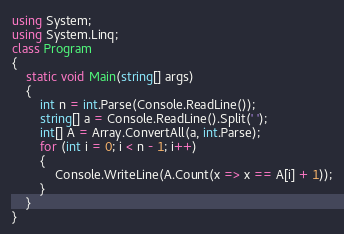Convert code to text. <code><loc_0><loc_0><loc_500><loc_500><_C#_>using System;
using System.Linq;
class Program
{
    static void Main(string[] args)
    {
        int n = int.Parse(Console.ReadLine());
        string[] a = Console.ReadLine().Split(' ');
        int[] A = Array.ConvertAll(a, int.Parse);
        for (int i = 0; i < n - 1; i++)
        {
            Console.WriteLine(A.Count(x => x == A[i] + 1));
        }
    }
}</code> 